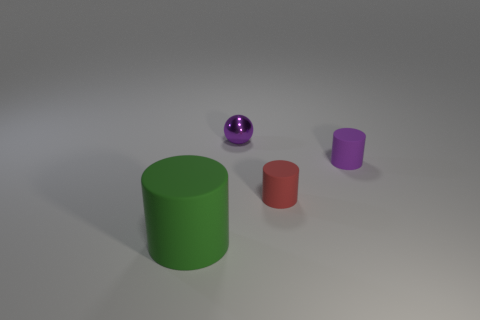Add 4 large cylinders. How many objects exist? 8 Subtract all spheres. How many objects are left? 3 Subtract 0 green blocks. How many objects are left? 4 Subtract all purple matte objects. Subtract all small red cylinders. How many objects are left? 2 Add 4 small red matte cylinders. How many small red matte cylinders are left? 5 Add 4 large gray matte spheres. How many large gray matte spheres exist? 4 